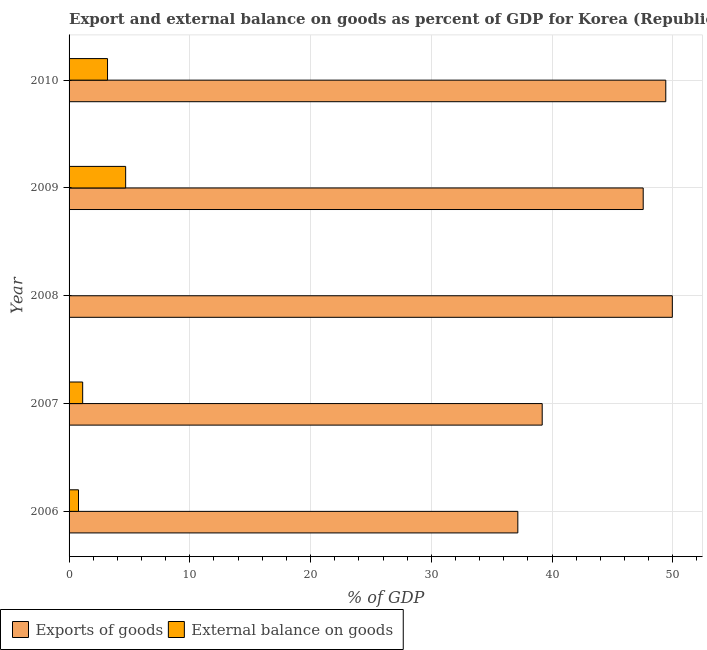Are the number of bars per tick equal to the number of legend labels?
Keep it short and to the point. No. Are the number of bars on each tick of the Y-axis equal?
Offer a very short reply. No. How many bars are there on the 3rd tick from the bottom?
Offer a terse response. 1. What is the label of the 2nd group of bars from the top?
Provide a short and direct response. 2009. What is the external balance on goods as percentage of gdp in 2010?
Provide a succinct answer. 3.18. Across all years, what is the maximum export of goods as percentage of gdp?
Make the answer very short. 49.96. Across all years, what is the minimum export of goods as percentage of gdp?
Provide a short and direct response. 37.17. What is the total export of goods as percentage of gdp in the graph?
Provide a succinct answer. 223.28. What is the difference between the external balance on goods as percentage of gdp in 2007 and that in 2009?
Keep it short and to the point. -3.56. What is the difference between the external balance on goods as percentage of gdp in 2008 and the export of goods as percentage of gdp in 2007?
Offer a very short reply. -39.18. What is the average external balance on goods as percentage of gdp per year?
Make the answer very short. 1.96. In the year 2006, what is the difference between the export of goods as percentage of gdp and external balance on goods as percentage of gdp?
Your answer should be very brief. 36.38. In how many years, is the export of goods as percentage of gdp greater than 6 %?
Provide a short and direct response. 5. What is the difference between the highest and the second highest external balance on goods as percentage of gdp?
Offer a very short reply. 1.5. In how many years, is the external balance on goods as percentage of gdp greater than the average external balance on goods as percentage of gdp taken over all years?
Ensure brevity in your answer.  2. Are all the bars in the graph horizontal?
Your response must be concise. Yes. How many years are there in the graph?
Your answer should be compact. 5. What is the difference between two consecutive major ticks on the X-axis?
Keep it short and to the point. 10. Are the values on the major ticks of X-axis written in scientific E-notation?
Offer a very short reply. No. Where does the legend appear in the graph?
Provide a succinct answer. Bottom left. How many legend labels are there?
Ensure brevity in your answer.  2. What is the title of the graph?
Provide a succinct answer. Export and external balance on goods as percent of GDP for Korea (Republic). What is the label or title of the X-axis?
Keep it short and to the point. % of GDP. What is the % of GDP of Exports of goods in 2006?
Keep it short and to the point. 37.17. What is the % of GDP in External balance on goods in 2006?
Provide a succinct answer. 0.78. What is the % of GDP in Exports of goods in 2007?
Provide a short and direct response. 39.18. What is the % of GDP of External balance on goods in 2007?
Your answer should be compact. 1.13. What is the % of GDP in Exports of goods in 2008?
Keep it short and to the point. 49.96. What is the % of GDP of External balance on goods in 2008?
Your answer should be compact. 0. What is the % of GDP of Exports of goods in 2009?
Provide a succinct answer. 47.55. What is the % of GDP of External balance on goods in 2009?
Ensure brevity in your answer.  4.69. What is the % of GDP in Exports of goods in 2010?
Ensure brevity in your answer.  49.42. What is the % of GDP of External balance on goods in 2010?
Your answer should be very brief. 3.18. Across all years, what is the maximum % of GDP in Exports of goods?
Offer a very short reply. 49.96. Across all years, what is the maximum % of GDP of External balance on goods?
Make the answer very short. 4.69. Across all years, what is the minimum % of GDP in Exports of goods?
Your answer should be compact. 37.17. What is the total % of GDP of Exports of goods in the graph?
Give a very brief answer. 223.28. What is the total % of GDP of External balance on goods in the graph?
Provide a succinct answer. 9.78. What is the difference between the % of GDP of Exports of goods in 2006 and that in 2007?
Your answer should be compact. -2.02. What is the difference between the % of GDP in External balance on goods in 2006 and that in 2007?
Provide a short and direct response. -0.35. What is the difference between the % of GDP of Exports of goods in 2006 and that in 2008?
Offer a terse response. -12.8. What is the difference between the % of GDP of Exports of goods in 2006 and that in 2009?
Offer a very short reply. -10.38. What is the difference between the % of GDP in External balance on goods in 2006 and that in 2009?
Make the answer very short. -3.91. What is the difference between the % of GDP of Exports of goods in 2006 and that in 2010?
Provide a succinct answer. -12.25. What is the difference between the % of GDP in External balance on goods in 2006 and that in 2010?
Your answer should be very brief. -2.4. What is the difference between the % of GDP in Exports of goods in 2007 and that in 2008?
Ensure brevity in your answer.  -10.78. What is the difference between the % of GDP in Exports of goods in 2007 and that in 2009?
Your answer should be compact. -8.37. What is the difference between the % of GDP in External balance on goods in 2007 and that in 2009?
Keep it short and to the point. -3.56. What is the difference between the % of GDP in Exports of goods in 2007 and that in 2010?
Your response must be concise. -10.23. What is the difference between the % of GDP in External balance on goods in 2007 and that in 2010?
Give a very brief answer. -2.06. What is the difference between the % of GDP in Exports of goods in 2008 and that in 2009?
Provide a short and direct response. 2.41. What is the difference between the % of GDP in Exports of goods in 2008 and that in 2010?
Keep it short and to the point. 0.54. What is the difference between the % of GDP in Exports of goods in 2009 and that in 2010?
Offer a very short reply. -1.87. What is the difference between the % of GDP in External balance on goods in 2009 and that in 2010?
Offer a terse response. 1.5. What is the difference between the % of GDP of Exports of goods in 2006 and the % of GDP of External balance on goods in 2007?
Provide a succinct answer. 36.04. What is the difference between the % of GDP of Exports of goods in 2006 and the % of GDP of External balance on goods in 2009?
Provide a short and direct response. 32.48. What is the difference between the % of GDP of Exports of goods in 2006 and the % of GDP of External balance on goods in 2010?
Offer a very short reply. 33.98. What is the difference between the % of GDP of Exports of goods in 2007 and the % of GDP of External balance on goods in 2009?
Offer a terse response. 34.5. What is the difference between the % of GDP of Exports of goods in 2007 and the % of GDP of External balance on goods in 2010?
Keep it short and to the point. 36. What is the difference between the % of GDP of Exports of goods in 2008 and the % of GDP of External balance on goods in 2009?
Offer a very short reply. 45.27. What is the difference between the % of GDP in Exports of goods in 2008 and the % of GDP in External balance on goods in 2010?
Offer a terse response. 46.78. What is the difference between the % of GDP in Exports of goods in 2009 and the % of GDP in External balance on goods in 2010?
Keep it short and to the point. 44.36. What is the average % of GDP of Exports of goods per year?
Give a very brief answer. 44.66. What is the average % of GDP of External balance on goods per year?
Keep it short and to the point. 1.96. In the year 2006, what is the difference between the % of GDP in Exports of goods and % of GDP in External balance on goods?
Provide a short and direct response. 36.39. In the year 2007, what is the difference between the % of GDP in Exports of goods and % of GDP in External balance on goods?
Ensure brevity in your answer.  38.06. In the year 2009, what is the difference between the % of GDP of Exports of goods and % of GDP of External balance on goods?
Provide a succinct answer. 42.86. In the year 2010, what is the difference between the % of GDP of Exports of goods and % of GDP of External balance on goods?
Keep it short and to the point. 46.23. What is the ratio of the % of GDP of Exports of goods in 2006 to that in 2007?
Ensure brevity in your answer.  0.95. What is the ratio of the % of GDP of External balance on goods in 2006 to that in 2007?
Offer a very short reply. 0.69. What is the ratio of the % of GDP of Exports of goods in 2006 to that in 2008?
Give a very brief answer. 0.74. What is the ratio of the % of GDP of Exports of goods in 2006 to that in 2009?
Provide a short and direct response. 0.78. What is the ratio of the % of GDP of Exports of goods in 2006 to that in 2010?
Offer a very short reply. 0.75. What is the ratio of the % of GDP of External balance on goods in 2006 to that in 2010?
Offer a terse response. 0.25. What is the ratio of the % of GDP of Exports of goods in 2007 to that in 2008?
Your response must be concise. 0.78. What is the ratio of the % of GDP of Exports of goods in 2007 to that in 2009?
Offer a very short reply. 0.82. What is the ratio of the % of GDP in External balance on goods in 2007 to that in 2009?
Offer a terse response. 0.24. What is the ratio of the % of GDP of Exports of goods in 2007 to that in 2010?
Ensure brevity in your answer.  0.79. What is the ratio of the % of GDP in External balance on goods in 2007 to that in 2010?
Offer a very short reply. 0.35. What is the ratio of the % of GDP in Exports of goods in 2008 to that in 2009?
Your response must be concise. 1.05. What is the ratio of the % of GDP of Exports of goods in 2008 to that in 2010?
Your answer should be compact. 1.01. What is the ratio of the % of GDP in Exports of goods in 2009 to that in 2010?
Offer a terse response. 0.96. What is the ratio of the % of GDP in External balance on goods in 2009 to that in 2010?
Ensure brevity in your answer.  1.47. What is the difference between the highest and the second highest % of GDP of Exports of goods?
Offer a very short reply. 0.54. What is the difference between the highest and the second highest % of GDP in External balance on goods?
Keep it short and to the point. 1.5. What is the difference between the highest and the lowest % of GDP in Exports of goods?
Keep it short and to the point. 12.8. What is the difference between the highest and the lowest % of GDP of External balance on goods?
Make the answer very short. 4.69. 